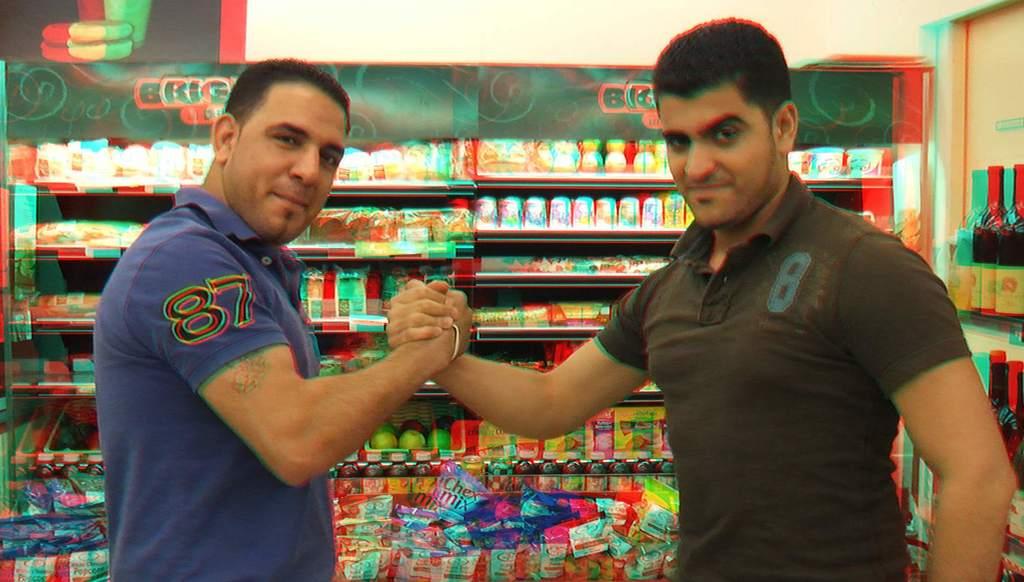What number was written on the blue shirt?
Offer a terse response. 87. 